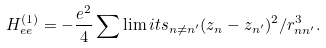<formula> <loc_0><loc_0><loc_500><loc_500>H _ { e e } ^ { ( 1 ) } = - \frac { e ^ { 2 } } { 4 } \sum \lim i t s _ { n \neq n ^ { \prime } } ( z _ { n } - z _ { n ^ { \prime } } ) ^ { 2 } / r _ { n n ^ { \prime } } ^ { 3 } .</formula> 